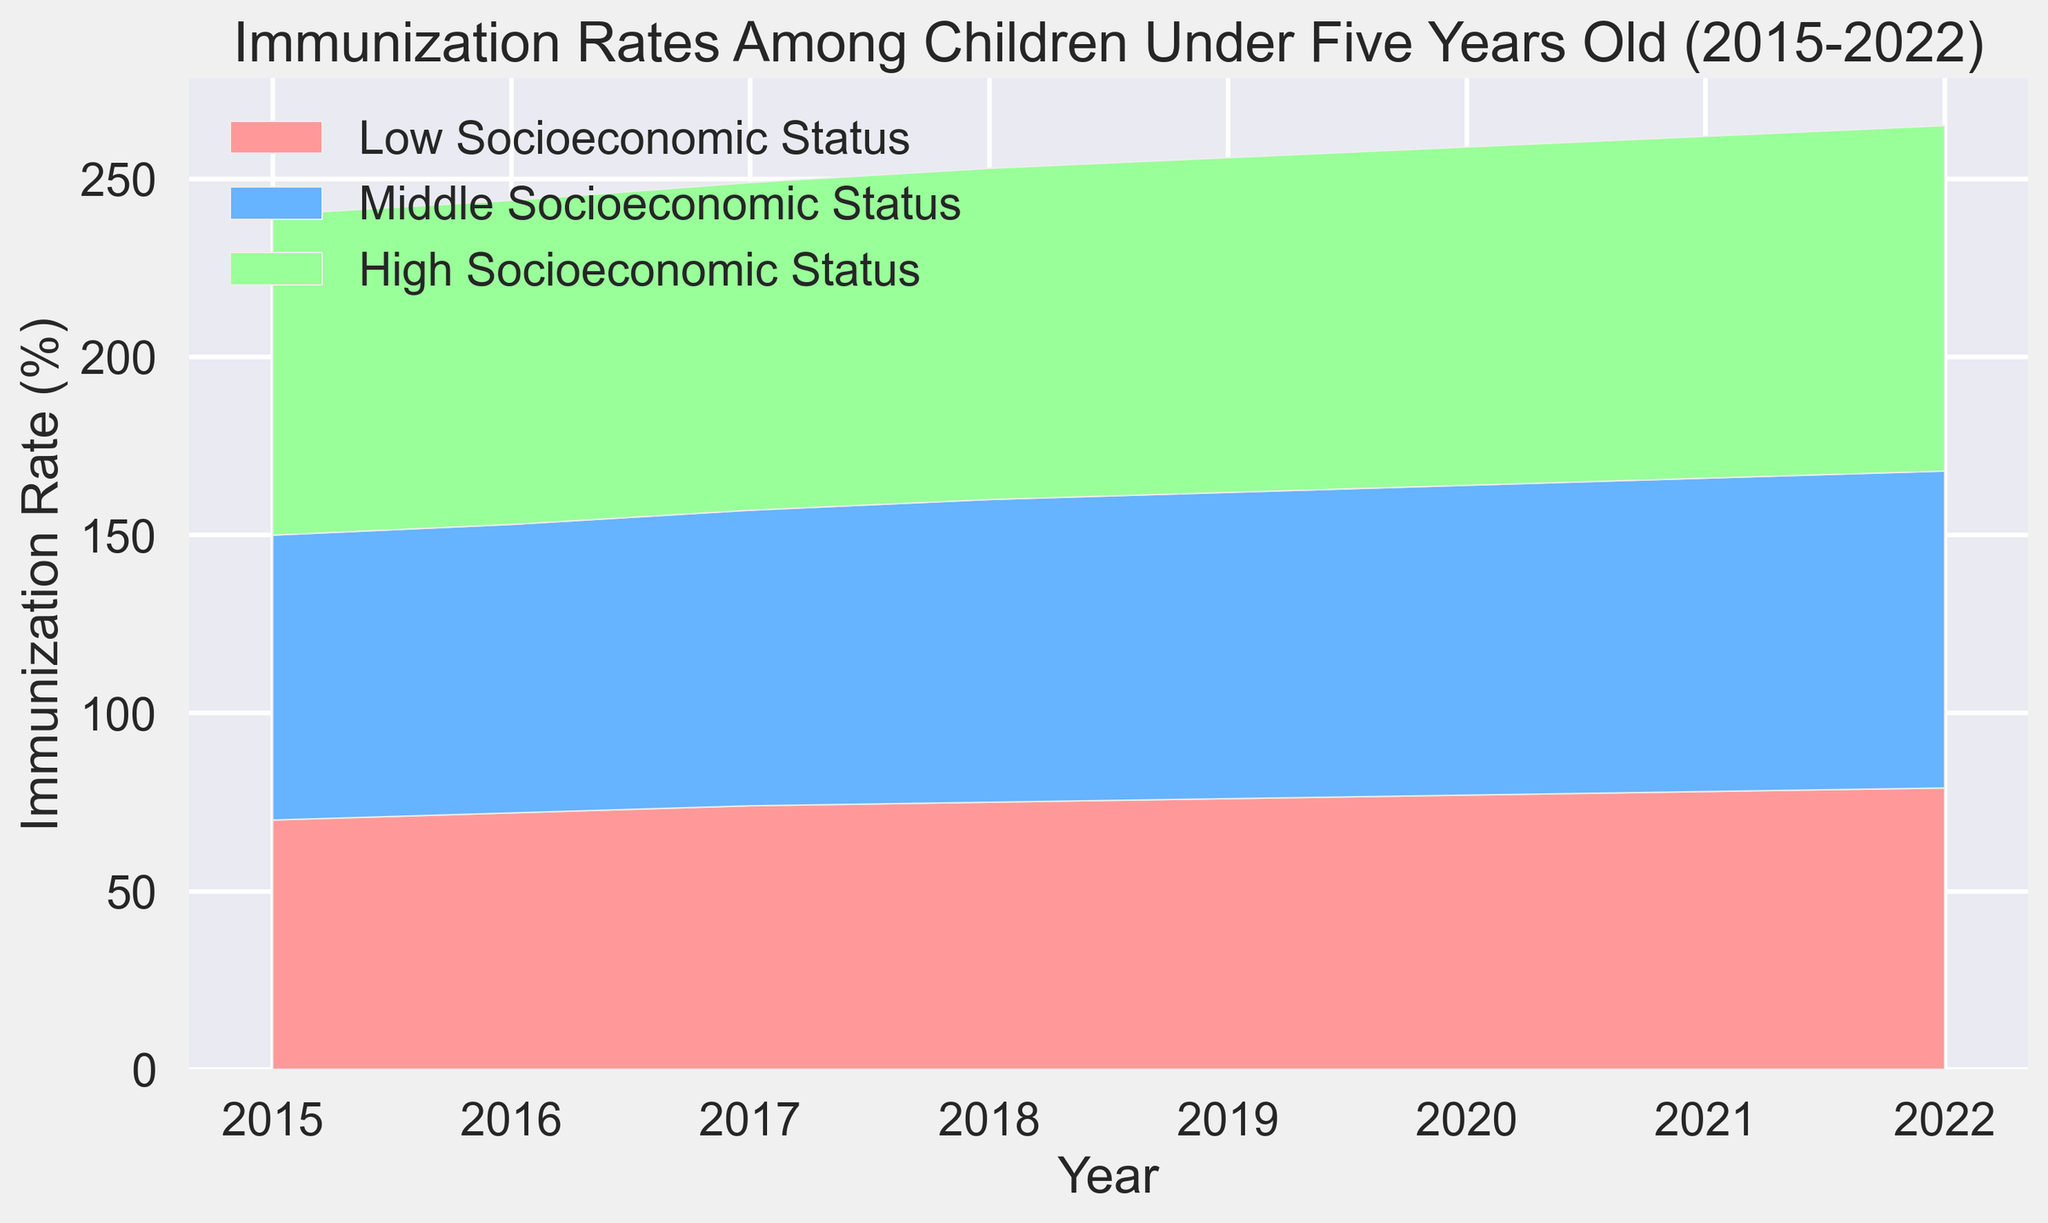What was the immunization rate for children under five years old from low socioeconomic status in 2018? Locate the year 2018 on the x-axis and find the corresponding immunization rate for the "Low Socioeconomic Status" group by looking at the height of the red area.
Answer: 75% What is the difference in immunization rates between children from high and low socioeconomic statuses in 2022? Locate the year 2022 on the x-axis. Find the immunization rates for both low (red area) and high (green area) socioeconomic statuses. Subtract the low rate from the high rate (97% - 79%).
Answer: 18% How did the immunization rate for children in the middle socioeconomic status group change from 2015 to 2020? Find the immunization rates for children in the "Middle Socioeconomic Status" group for the years 2015 (80%) and 2020 (87%). Subtract the 2015 rate from the 2020 rate (87% - 80%).
Answer: 7% By observing the colors, which socioeconomic status group has consistently had the highest immunization rate from 2015 to 2022? The green area represents the "High Socioeconomic Status" group and is always on top in the stacked area chart, indicating the highest immunization rates throughout the years.
Answer: High Socioeconomic Status Which year shows the largest increase in immunization rates for children from the low socioeconomic status group? Look for the year-to-year changes in the red area representing the "Low Socioeconomic Status." The largest increase occurs between 2016 (72%) and 2017 (74%), which is an increase of 2%.
Answer: 2017 What is the average immunization rate over the years for children from the high socioeconomic status group? Sum the immunization rates for the high socioeconomic status group from 2015 to 2022, which are (90% + 91% + 92% + 93% + 94% + 95% + 96% + 97%). Divide the total by the number of years (8). (90 + 91 + 92 + 93 + 94 + 95 + 96 + 97)/8 = 738/8.
Answer: 92.25% In which year did all three socioeconomic status groups see an increase in immunization rates compared to the previous year? Compare the immunization rates yearly for all three groups. In 2016, all groups (Low 72%, Middle 81%, High 91%) have higher rates than in 2015 (Low 70%, Middle 80%, High 90%).
Answer: 2016 